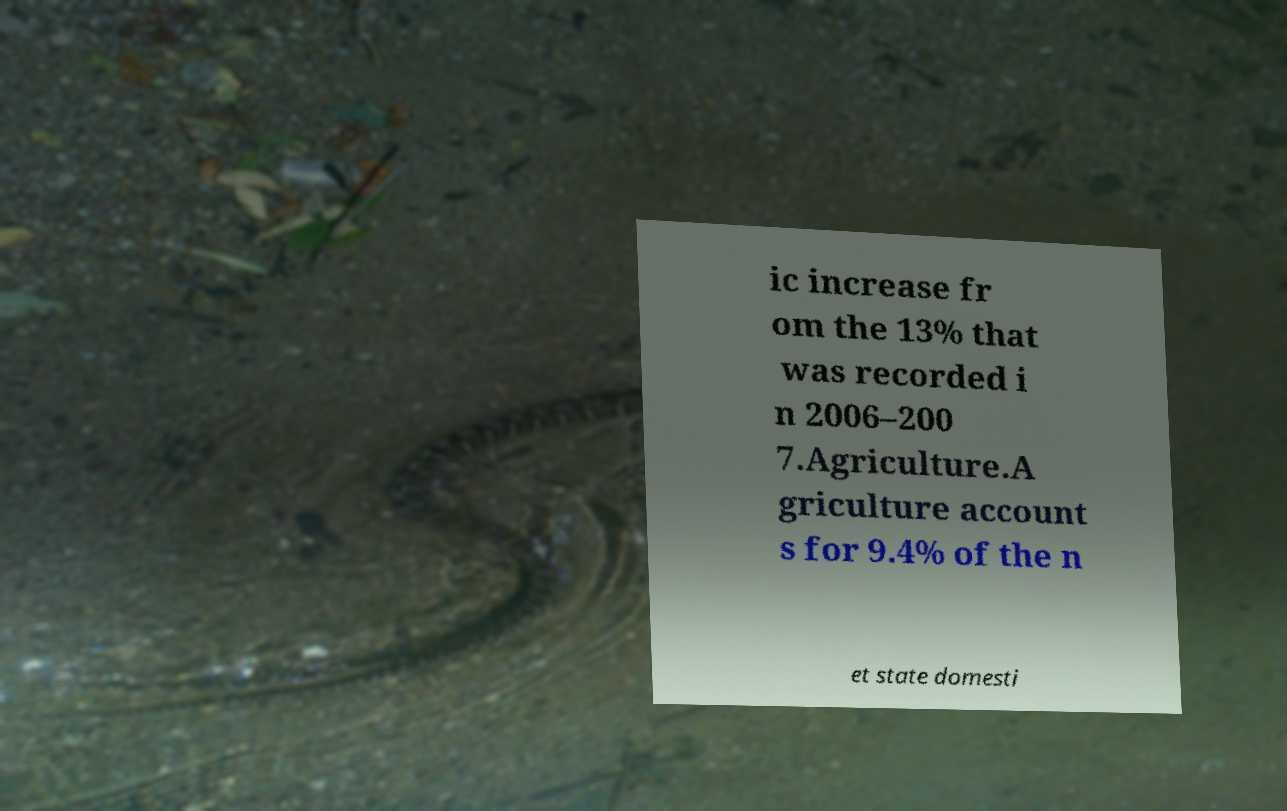Please read and relay the text visible in this image. What does it say? ic increase fr om the 13% that was recorded i n 2006–200 7.Agriculture.A griculture account s for 9.4% of the n et state domesti 